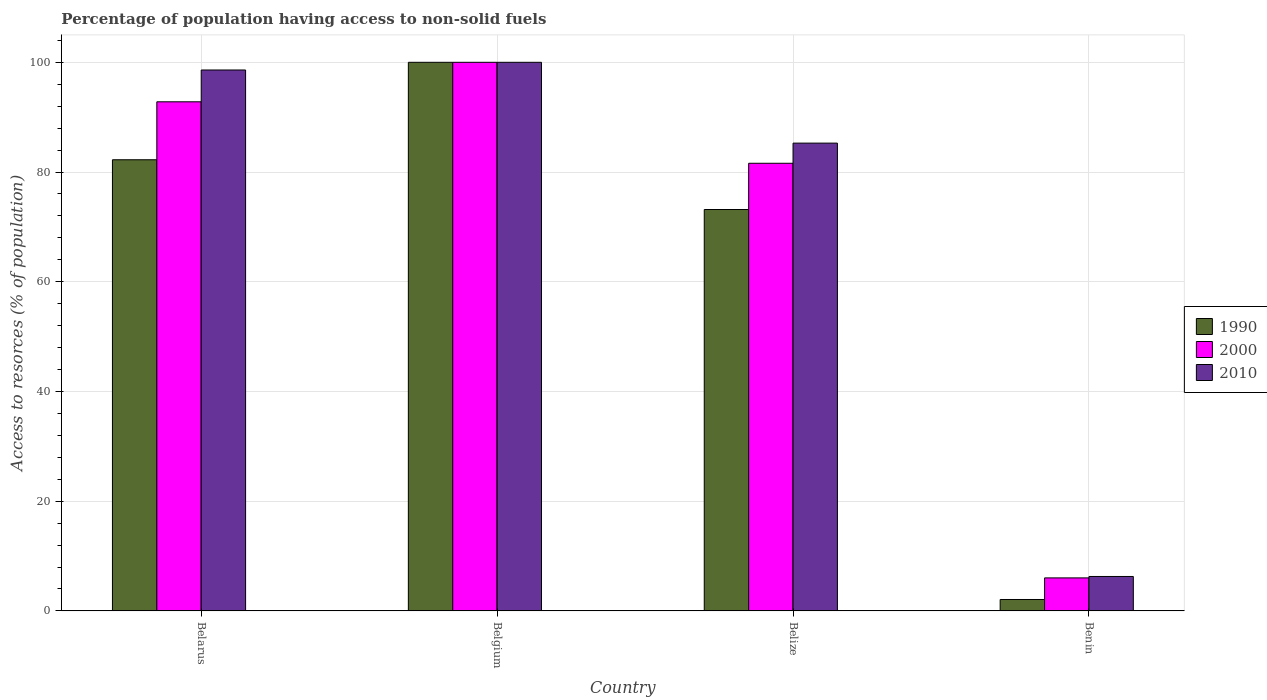How many different coloured bars are there?
Your answer should be very brief. 3. How many bars are there on the 3rd tick from the left?
Your answer should be compact. 3. What is the label of the 3rd group of bars from the left?
Ensure brevity in your answer.  Belize. What is the percentage of population having access to non-solid fuels in 2000 in Belize?
Your answer should be very brief. 81.6. Across all countries, what is the minimum percentage of population having access to non-solid fuels in 2010?
Offer a very short reply. 6.27. In which country was the percentage of population having access to non-solid fuels in 2000 minimum?
Make the answer very short. Benin. What is the total percentage of population having access to non-solid fuels in 2000 in the graph?
Offer a very short reply. 280.41. What is the difference between the percentage of population having access to non-solid fuels in 1990 in Belarus and that in Belgium?
Give a very brief answer. -17.76. What is the difference between the percentage of population having access to non-solid fuels in 1990 in Belgium and the percentage of population having access to non-solid fuels in 2000 in Belarus?
Make the answer very short. 7.2. What is the average percentage of population having access to non-solid fuels in 1990 per country?
Provide a succinct answer. 64.37. What is the difference between the percentage of population having access to non-solid fuels of/in 2000 and percentage of population having access to non-solid fuels of/in 2010 in Belarus?
Make the answer very short. -5.8. What is the ratio of the percentage of population having access to non-solid fuels in 2010 in Belarus to that in Belgium?
Give a very brief answer. 0.99. Is the percentage of population having access to non-solid fuels in 2010 in Belgium less than that in Benin?
Ensure brevity in your answer.  No. Is the difference between the percentage of population having access to non-solid fuels in 2000 in Belarus and Belgium greater than the difference between the percentage of population having access to non-solid fuels in 2010 in Belarus and Belgium?
Make the answer very short. No. What is the difference between the highest and the second highest percentage of population having access to non-solid fuels in 2010?
Ensure brevity in your answer.  -1.4. What is the difference between the highest and the lowest percentage of population having access to non-solid fuels in 2000?
Your answer should be very brief. 93.98. What does the 3rd bar from the right in Belize represents?
Offer a very short reply. 1990. How many bars are there?
Your answer should be very brief. 12. Does the graph contain grids?
Offer a terse response. Yes. Where does the legend appear in the graph?
Give a very brief answer. Center right. How many legend labels are there?
Your answer should be very brief. 3. What is the title of the graph?
Your answer should be compact. Percentage of population having access to non-solid fuels. What is the label or title of the X-axis?
Offer a terse response. Country. What is the label or title of the Y-axis?
Keep it short and to the point. Access to resorces (% of population). What is the Access to resorces (% of population) of 1990 in Belarus?
Your answer should be compact. 82.24. What is the Access to resorces (% of population) in 2000 in Belarus?
Offer a very short reply. 92.8. What is the Access to resorces (% of population) in 2010 in Belarus?
Make the answer very short. 98.6. What is the Access to resorces (% of population) in 2000 in Belgium?
Your answer should be very brief. 100. What is the Access to resorces (% of population) of 1990 in Belize?
Your response must be concise. 73.17. What is the Access to resorces (% of population) in 2000 in Belize?
Keep it short and to the point. 81.6. What is the Access to resorces (% of population) in 2010 in Belize?
Your answer should be very brief. 85.27. What is the Access to resorces (% of population) of 1990 in Benin?
Make the answer very short. 2.08. What is the Access to resorces (% of population) of 2000 in Benin?
Your response must be concise. 6.02. What is the Access to resorces (% of population) in 2010 in Benin?
Make the answer very short. 6.27. Across all countries, what is the maximum Access to resorces (% of population) of 1990?
Provide a succinct answer. 100. Across all countries, what is the maximum Access to resorces (% of population) in 2000?
Give a very brief answer. 100. Across all countries, what is the minimum Access to resorces (% of population) in 1990?
Provide a succinct answer. 2.08. Across all countries, what is the minimum Access to resorces (% of population) of 2000?
Your response must be concise. 6.02. Across all countries, what is the minimum Access to resorces (% of population) of 2010?
Ensure brevity in your answer.  6.27. What is the total Access to resorces (% of population) of 1990 in the graph?
Keep it short and to the point. 257.48. What is the total Access to resorces (% of population) of 2000 in the graph?
Your answer should be compact. 280.41. What is the total Access to resorces (% of population) of 2010 in the graph?
Ensure brevity in your answer.  290.14. What is the difference between the Access to resorces (% of population) in 1990 in Belarus and that in Belgium?
Offer a very short reply. -17.76. What is the difference between the Access to resorces (% of population) in 2000 in Belarus and that in Belgium?
Your response must be concise. -7.2. What is the difference between the Access to resorces (% of population) in 2010 in Belarus and that in Belgium?
Your answer should be very brief. -1.4. What is the difference between the Access to resorces (% of population) in 1990 in Belarus and that in Belize?
Your response must be concise. 9.07. What is the difference between the Access to resorces (% of population) of 2000 in Belarus and that in Belize?
Give a very brief answer. 11.2. What is the difference between the Access to resorces (% of population) of 2010 in Belarus and that in Belize?
Make the answer very short. 13.33. What is the difference between the Access to resorces (% of population) in 1990 in Belarus and that in Benin?
Offer a very short reply. 80.16. What is the difference between the Access to resorces (% of population) of 2000 in Belarus and that in Benin?
Offer a very short reply. 86.79. What is the difference between the Access to resorces (% of population) of 2010 in Belarus and that in Benin?
Provide a short and direct response. 92.33. What is the difference between the Access to resorces (% of population) of 1990 in Belgium and that in Belize?
Offer a very short reply. 26.83. What is the difference between the Access to resorces (% of population) in 2000 in Belgium and that in Belize?
Offer a terse response. 18.4. What is the difference between the Access to resorces (% of population) of 2010 in Belgium and that in Belize?
Offer a terse response. 14.73. What is the difference between the Access to resorces (% of population) in 1990 in Belgium and that in Benin?
Make the answer very short. 97.92. What is the difference between the Access to resorces (% of population) in 2000 in Belgium and that in Benin?
Offer a very short reply. 93.98. What is the difference between the Access to resorces (% of population) of 2010 in Belgium and that in Benin?
Your answer should be compact. 93.73. What is the difference between the Access to resorces (% of population) of 1990 in Belize and that in Benin?
Provide a succinct answer. 71.09. What is the difference between the Access to resorces (% of population) in 2000 in Belize and that in Benin?
Your response must be concise. 75.58. What is the difference between the Access to resorces (% of population) of 2010 in Belize and that in Benin?
Ensure brevity in your answer.  79. What is the difference between the Access to resorces (% of population) in 1990 in Belarus and the Access to resorces (% of population) in 2000 in Belgium?
Provide a succinct answer. -17.76. What is the difference between the Access to resorces (% of population) in 1990 in Belarus and the Access to resorces (% of population) in 2010 in Belgium?
Keep it short and to the point. -17.76. What is the difference between the Access to resorces (% of population) in 2000 in Belarus and the Access to resorces (% of population) in 2010 in Belgium?
Your answer should be very brief. -7.2. What is the difference between the Access to resorces (% of population) of 1990 in Belarus and the Access to resorces (% of population) of 2000 in Belize?
Give a very brief answer. 0.64. What is the difference between the Access to resorces (% of population) in 1990 in Belarus and the Access to resorces (% of population) in 2010 in Belize?
Your answer should be compact. -3.03. What is the difference between the Access to resorces (% of population) in 2000 in Belarus and the Access to resorces (% of population) in 2010 in Belize?
Provide a short and direct response. 7.53. What is the difference between the Access to resorces (% of population) of 1990 in Belarus and the Access to resorces (% of population) of 2000 in Benin?
Ensure brevity in your answer.  76.22. What is the difference between the Access to resorces (% of population) in 1990 in Belarus and the Access to resorces (% of population) in 2010 in Benin?
Your response must be concise. 75.96. What is the difference between the Access to resorces (% of population) in 2000 in Belarus and the Access to resorces (% of population) in 2010 in Benin?
Keep it short and to the point. 86.53. What is the difference between the Access to resorces (% of population) in 1990 in Belgium and the Access to resorces (% of population) in 2000 in Belize?
Ensure brevity in your answer.  18.4. What is the difference between the Access to resorces (% of population) in 1990 in Belgium and the Access to resorces (% of population) in 2010 in Belize?
Offer a terse response. 14.73. What is the difference between the Access to resorces (% of population) of 2000 in Belgium and the Access to resorces (% of population) of 2010 in Belize?
Your response must be concise. 14.73. What is the difference between the Access to resorces (% of population) of 1990 in Belgium and the Access to resorces (% of population) of 2000 in Benin?
Offer a very short reply. 93.98. What is the difference between the Access to resorces (% of population) in 1990 in Belgium and the Access to resorces (% of population) in 2010 in Benin?
Make the answer very short. 93.73. What is the difference between the Access to resorces (% of population) in 2000 in Belgium and the Access to resorces (% of population) in 2010 in Benin?
Your answer should be compact. 93.73. What is the difference between the Access to resorces (% of population) in 1990 in Belize and the Access to resorces (% of population) in 2000 in Benin?
Your answer should be compact. 67.15. What is the difference between the Access to resorces (% of population) in 1990 in Belize and the Access to resorces (% of population) in 2010 in Benin?
Your answer should be compact. 66.89. What is the difference between the Access to resorces (% of population) in 2000 in Belize and the Access to resorces (% of population) in 2010 in Benin?
Offer a terse response. 75.32. What is the average Access to resorces (% of population) of 1990 per country?
Offer a very short reply. 64.37. What is the average Access to resorces (% of population) of 2000 per country?
Provide a succinct answer. 70.1. What is the average Access to resorces (% of population) of 2010 per country?
Offer a very short reply. 72.54. What is the difference between the Access to resorces (% of population) in 1990 and Access to resorces (% of population) in 2000 in Belarus?
Offer a terse response. -10.56. What is the difference between the Access to resorces (% of population) of 1990 and Access to resorces (% of population) of 2010 in Belarus?
Provide a short and direct response. -16.36. What is the difference between the Access to resorces (% of population) of 2000 and Access to resorces (% of population) of 2010 in Belarus?
Your answer should be very brief. -5.8. What is the difference between the Access to resorces (% of population) of 1990 and Access to resorces (% of population) of 2000 in Belgium?
Provide a succinct answer. 0. What is the difference between the Access to resorces (% of population) of 2000 and Access to resorces (% of population) of 2010 in Belgium?
Give a very brief answer. 0. What is the difference between the Access to resorces (% of population) in 1990 and Access to resorces (% of population) in 2000 in Belize?
Make the answer very short. -8.43. What is the difference between the Access to resorces (% of population) of 1990 and Access to resorces (% of population) of 2010 in Belize?
Give a very brief answer. -12.1. What is the difference between the Access to resorces (% of population) in 2000 and Access to resorces (% of population) in 2010 in Belize?
Give a very brief answer. -3.67. What is the difference between the Access to resorces (% of population) in 1990 and Access to resorces (% of population) in 2000 in Benin?
Your answer should be very brief. -3.94. What is the difference between the Access to resorces (% of population) of 1990 and Access to resorces (% of population) of 2010 in Benin?
Your response must be concise. -4.19. What is the difference between the Access to resorces (% of population) in 2000 and Access to resorces (% of population) in 2010 in Benin?
Offer a terse response. -0.26. What is the ratio of the Access to resorces (% of population) in 1990 in Belarus to that in Belgium?
Offer a terse response. 0.82. What is the ratio of the Access to resorces (% of population) of 2000 in Belarus to that in Belgium?
Your answer should be compact. 0.93. What is the ratio of the Access to resorces (% of population) in 2010 in Belarus to that in Belgium?
Provide a short and direct response. 0.99. What is the ratio of the Access to resorces (% of population) of 1990 in Belarus to that in Belize?
Keep it short and to the point. 1.12. What is the ratio of the Access to resorces (% of population) of 2000 in Belarus to that in Belize?
Provide a short and direct response. 1.14. What is the ratio of the Access to resorces (% of population) in 2010 in Belarus to that in Belize?
Your answer should be very brief. 1.16. What is the ratio of the Access to resorces (% of population) in 1990 in Belarus to that in Benin?
Provide a succinct answer. 39.55. What is the ratio of the Access to resorces (% of population) of 2000 in Belarus to that in Benin?
Make the answer very short. 15.43. What is the ratio of the Access to resorces (% of population) in 2010 in Belarus to that in Benin?
Your response must be concise. 15.72. What is the ratio of the Access to resorces (% of population) in 1990 in Belgium to that in Belize?
Your answer should be compact. 1.37. What is the ratio of the Access to resorces (% of population) of 2000 in Belgium to that in Belize?
Offer a very short reply. 1.23. What is the ratio of the Access to resorces (% of population) in 2010 in Belgium to that in Belize?
Ensure brevity in your answer.  1.17. What is the ratio of the Access to resorces (% of population) in 1990 in Belgium to that in Benin?
Offer a very short reply. 48.09. What is the ratio of the Access to resorces (% of population) of 2000 in Belgium to that in Benin?
Offer a very short reply. 16.62. What is the ratio of the Access to resorces (% of population) in 2010 in Belgium to that in Benin?
Your response must be concise. 15.94. What is the ratio of the Access to resorces (% of population) in 1990 in Belize to that in Benin?
Offer a very short reply. 35.19. What is the ratio of the Access to resorces (% of population) in 2000 in Belize to that in Benin?
Make the answer very short. 13.57. What is the ratio of the Access to resorces (% of population) in 2010 in Belize to that in Benin?
Offer a terse response. 13.59. What is the difference between the highest and the second highest Access to resorces (% of population) of 1990?
Your response must be concise. 17.76. What is the difference between the highest and the second highest Access to resorces (% of population) in 2000?
Provide a succinct answer. 7.2. What is the difference between the highest and the second highest Access to resorces (% of population) of 2010?
Your answer should be very brief. 1.4. What is the difference between the highest and the lowest Access to resorces (% of population) of 1990?
Your answer should be very brief. 97.92. What is the difference between the highest and the lowest Access to resorces (% of population) of 2000?
Keep it short and to the point. 93.98. What is the difference between the highest and the lowest Access to resorces (% of population) in 2010?
Your answer should be very brief. 93.73. 